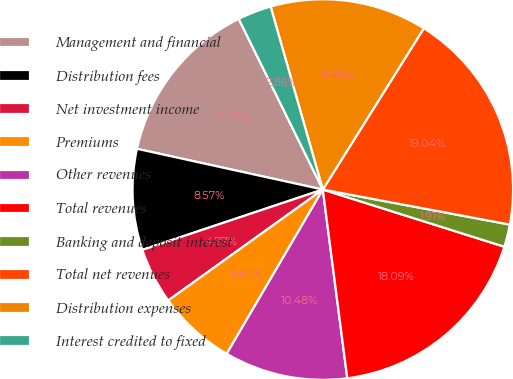Convert chart to OTSL. <chart><loc_0><loc_0><loc_500><loc_500><pie_chart><fcel>Management and financial<fcel>Distribution fees<fcel>Net investment income<fcel>Premiums<fcel>Other revenues<fcel>Total revenues<fcel>Banking and deposit interest<fcel>Total net revenues<fcel>Distribution expenses<fcel>Interest credited to fixed<nl><fcel>14.28%<fcel>8.57%<fcel>4.77%<fcel>6.67%<fcel>10.48%<fcel>18.09%<fcel>1.91%<fcel>19.04%<fcel>13.33%<fcel>2.86%<nl></chart> 